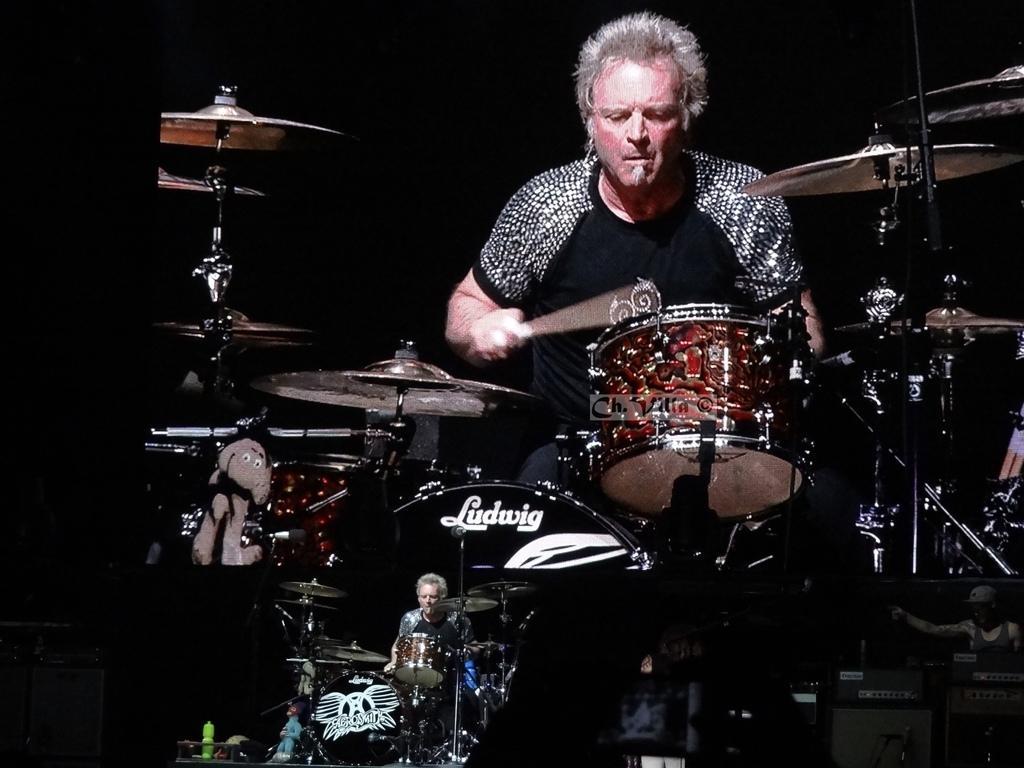Please provide a concise description of this image. In this picture a person is playing drums. At the bottom there are television screens, in the television screens there are people playing drums. The background is dark. 